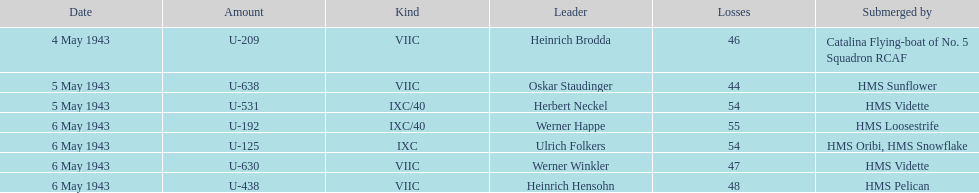Which submerged u-boat had the highest fatalities? U-192. 